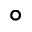<formula> <loc_0><loc_0><loc_500><loc_500>^ { \circ }</formula> 